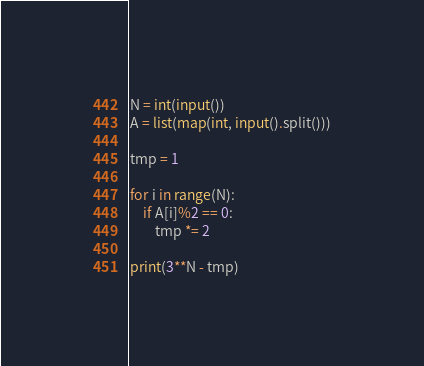<code> <loc_0><loc_0><loc_500><loc_500><_Python_>N = int(input())
A = list(map(int, input().split()))

tmp = 1

for i in range(N):
    if A[i]%2 == 0:
        tmp *= 2

print(3**N - tmp)</code> 